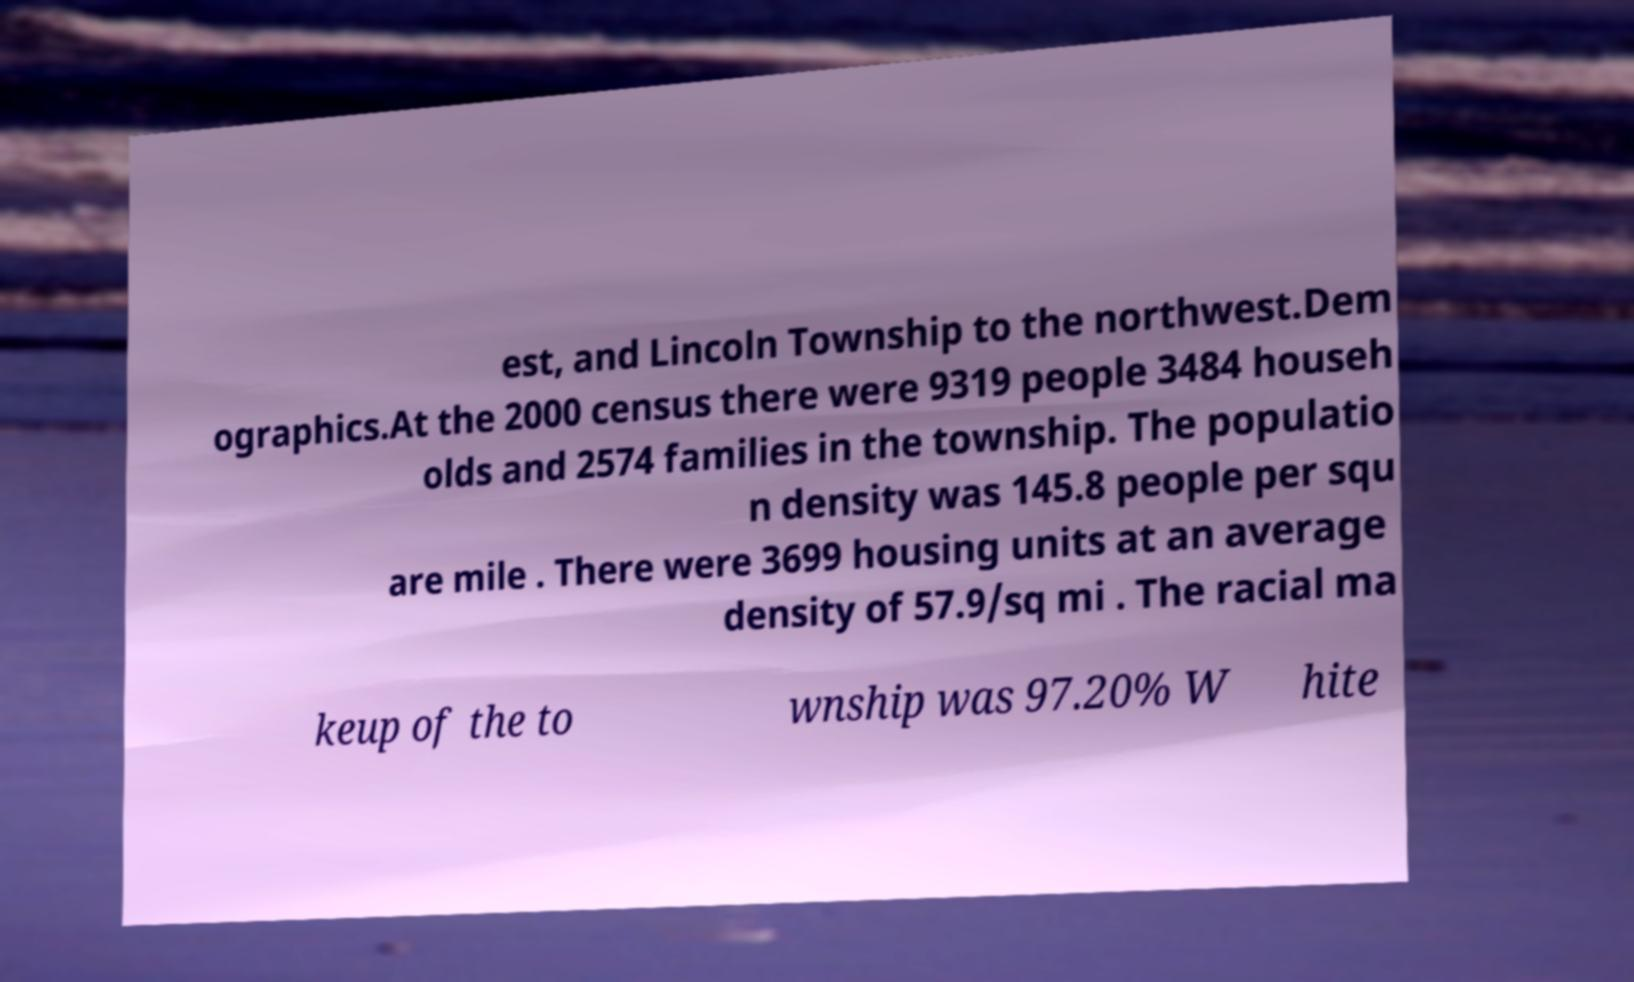For documentation purposes, I need the text within this image transcribed. Could you provide that? est, and Lincoln Township to the northwest.Dem ographics.At the 2000 census there were 9319 people 3484 househ olds and 2574 families in the township. The populatio n density was 145.8 people per squ are mile . There were 3699 housing units at an average density of 57.9/sq mi . The racial ma keup of the to wnship was 97.20% W hite 